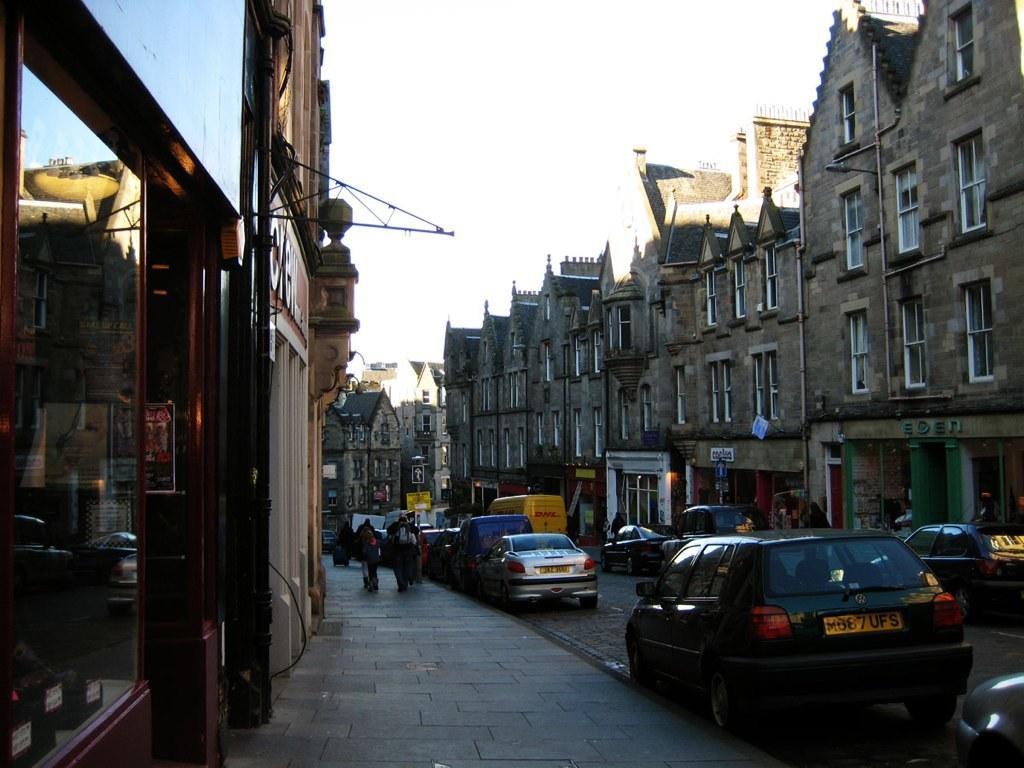Describe this image in one or two sentences. In this picture we can see few vehicles on the road. Some people are walking on the path. There are few buildings on right and left side of the road. We can see a board on the pole. Some other boards are visible on the building. 